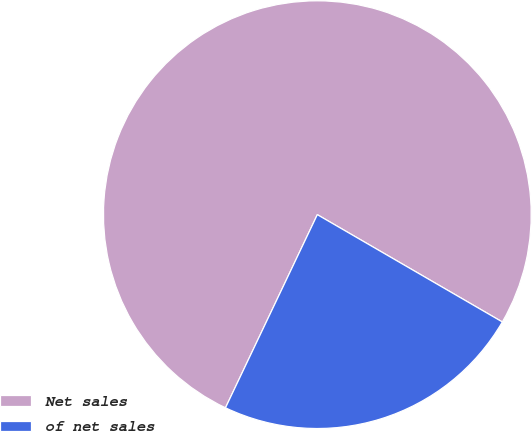Convert chart. <chart><loc_0><loc_0><loc_500><loc_500><pie_chart><fcel>Net sales<fcel>of net sales<nl><fcel>76.3%<fcel>23.7%<nl></chart> 